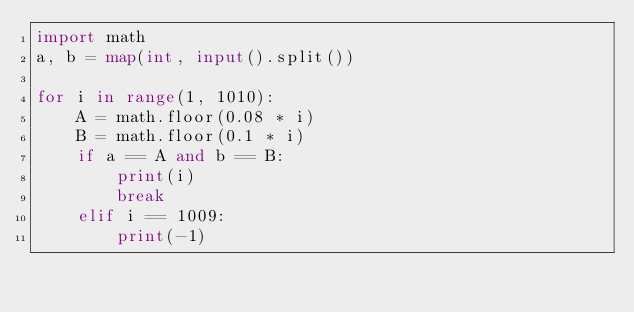<code> <loc_0><loc_0><loc_500><loc_500><_Python_>import math
a, b = map(int, input().split())

for i in range(1, 1010):
    A = math.floor(0.08 * i)
    B = math.floor(0.1 * i)
    if a == A and b == B:
        print(i)
        break
    elif i == 1009:
        print(-1)</code> 